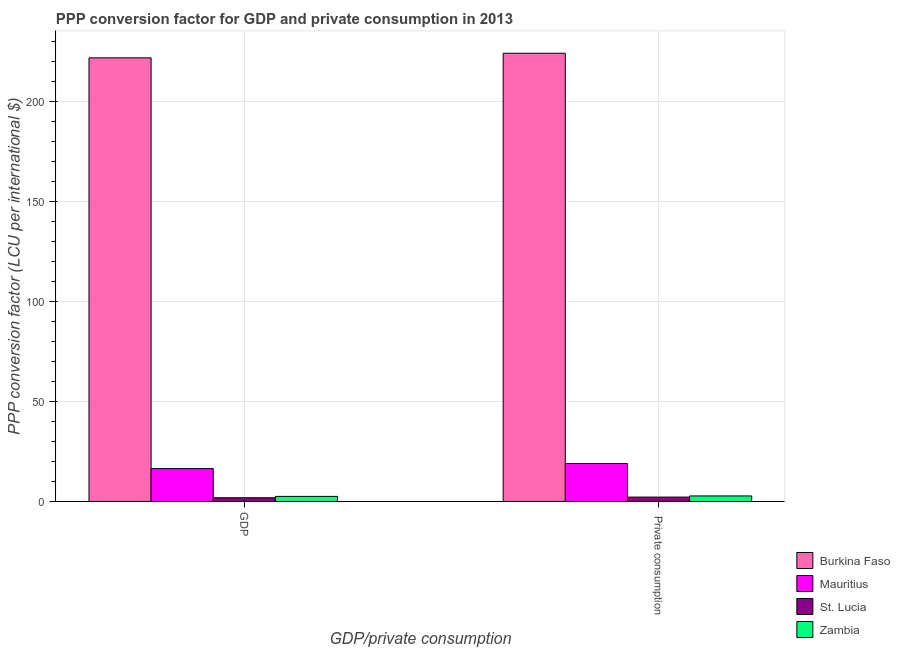How many different coloured bars are there?
Keep it short and to the point. 4. How many groups of bars are there?
Your response must be concise. 2. Are the number of bars per tick equal to the number of legend labels?
Your answer should be compact. Yes. Are the number of bars on each tick of the X-axis equal?
Your response must be concise. Yes. How many bars are there on the 1st tick from the right?
Give a very brief answer. 4. What is the label of the 2nd group of bars from the left?
Give a very brief answer.  Private consumption. What is the ppp conversion factor for private consumption in St. Lucia?
Your response must be concise. 2.18. Across all countries, what is the maximum ppp conversion factor for gdp?
Make the answer very short. 221.68. Across all countries, what is the minimum ppp conversion factor for gdp?
Offer a very short reply. 1.86. In which country was the ppp conversion factor for private consumption maximum?
Provide a short and direct response. Burkina Faso. In which country was the ppp conversion factor for gdp minimum?
Offer a very short reply. St. Lucia. What is the total ppp conversion factor for private consumption in the graph?
Offer a very short reply. 247.9. What is the difference between the ppp conversion factor for gdp in St. Lucia and that in Mauritius?
Ensure brevity in your answer.  -14.57. What is the difference between the ppp conversion factor for gdp in St. Lucia and the ppp conversion factor for private consumption in Mauritius?
Give a very brief answer. -17.12. What is the average ppp conversion factor for gdp per country?
Ensure brevity in your answer.  60.63. What is the difference between the ppp conversion factor for private consumption and ppp conversion factor for gdp in St. Lucia?
Ensure brevity in your answer.  0.32. In how many countries, is the ppp conversion factor for private consumption greater than 80 LCU?
Ensure brevity in your answer.  1. What is the ratio of the ppp conversion factor for gdp in Burkina Faso to that in Mauritius?
Your response must be concise. 13.49. What does the 3rd bar from the left in  Private consumption represents?
Give a very brief answer. St. Lucia. What does the 2nd bar from the right in GDP represents?
Make the answer very short. St. Lucia. How many countries are there in the graph?
Your response must be concise. 4. Are the values on the major ticks of Y-axis written in scientific E-notation?
Your answer should be very brief. No. What is the title of the graph?
Provide a succinct answer. PPP conversion factor for GDP and private consumption in 2013. What is the label or title of the X-axis?
Your answer should be very brief. GDP/private consumption. What is the label or title of the Y-axis?
Make the answer very short. PPP conversion factor (LCU per international $). What is the PPP conversion factor (LCU per international $) of Burkina Faso in GDP?
Give a very brief answer. 221.68. What is the PPP conversion factor (LCU per international $) of Mauritius in GDP?
Offer a very short reply. 16.43. What is the PPP conversion factor (LCU per international $) of St. Lucia in GDP?
Provide a short and direct response. 1.86. What is the PPP conversion factor (LCU per international $) in Zambia in GDP?
Provide a succinct answer. 2.54. What is the PPP conversion factor (LCU per international $) of Burkina Faso in  Private consumption?
Offer a very short reply. 223.98. What is the PPP conversion factor (LCU per international $) of Mauritius in  Private consumption?
Your answer should be compact. 18.99. What is the PPP conversion factor (LCU per international $) of St. Lucia in  Private consumption?
Keep it short and to the point. 2.18. What is the PPP conversion factor (LCU per international $) in Zambia in  Private consumption?
Make the answer very short. 2.76. Across all GDP/private consumption, what is the maximum PPP conversion factor (LCU per international $) in Burkina Faso?
Your answer should be compact. 223.98. Across all GDP/private consumption, what is the maximum PPP conversion factor (LCU per international $) in Mauritius?
Provide a succinct answer. 18.99. Across all GDP/private consumption, what is the maximum PPP conversion factor (LCU per international $) in St. Lucia?
Offer a very short reply. 2.18. Across all GDP/private consumption, what is the maximum PPP conversion factor (LCU per international $) of Zambia?
Offer a very short reply. 2.76. Across all GDP/private consumption, what is the minimum PPP conversion factor (LCU per international $) in Burkina Faso?
Provide a short and direct response. 221.68. Across all GDP/private consumption, what is the minimum PPP conversion factor (LCU per international $) of Mauritius?
Make the answer very short. 16.43. Across all GDP/private consumption, what is the minimum PPP conversion factor (LCU per international $) of St. Lucia?
Offer a terse response. 1.86. Across all GDP/private consumption, what is the minimum PPP conversion factor (LCU per international $) in Zambia?
Give a very brief answer. 2.54. What is the total PPP conversion factor (LCU per international $) in Burkina Faso in the graph?
Your answer should be very brief. 445.65. What is the total PPP conversion factor (LCU per international $) of Mauritius in the graph?
Give a very brief answer. 35.42. What is the total PPP conversion factor (LCU per international $) in St. Lucia in the graph?
Give a very brief answer. 4.05. What is the total PPP conversion factor (LCU per international $) in Zambia in the graph?
Offer a very short reply. 5.29. What is the difference between the PPP conversion factor (LCU per international $) in Burkina Faso in GDP and that in  Private consumption?
Make the answer very short. -2.3. What is the difference between the PPP conversion factor (LCU per international $) of Mauritius in GDP and that in  Private consumption?
Make the answer very short. -2.56. What is the difference between the PPP conversion factor (LCU per international $) in St. Lucia in GDP and that in  Private consumption?
Your response must be concise. -0.32. What is the difference between the PPP conversion factor (LCU per international $) in Zambia in GDP and that in  Private consumption?
Give a very brief answer. -0.22. What is the difference between the PPP conversion factor (LCU per international $) in Burkina Faso in GDP and the PPP conversion factor (LCU per international $) in Mauritius in  Private consumption?
Provide a succinct answer. 202.69. What is the difference between the PPP conversion factor (LCU per international $) in Burkina Faso in GDP and the PPP conversion factor (LCU per international $) in St. Lucia in  Private consumption?
Your answer should be very brief. 219.5. What is the difference between the PPP conversion factor (LCU per international $) of Burkina Faso in GDP and the PPP conversion factor (LCU per international $) of Zambia in  Private consumption?
Provide a succinct answer. 218.92. What is the difference between the PPP conversion factor (LCU per international $) in Mauritius in GDP and the PPP conversion factor (LCU per international $) in St. Lucia in  Private consumption?
Offer a terse response. 14.25. What is the difference between the PPP conversion factor (LCU per international $) in Mauritius in GDP and the PPP conversion factor (LCU per international $) in Zambia in  Private consumption?
Your answer should be very brief. 13.67. What is the difference between the PPP conversion factor (LCU per international $) of St. Lucia in GDP and the PPP conversion factor (LCU per international $) of Zambia in  Private consumption?
Give a very brief answer. -0.9. What is the average PPP conversion factor (LCU per international $) of Burkina Faso per GDP/private consumption?
Provide a succinct answer. 222.83. What is the average PPP conversion factor (LCU per international $) of Mauritius per GDP/private consumption?
Offer a very short reply. 17.71. What is the average PPP conversion factor (LCU per international $) in St. Lucia per GDP/private consumption?
Your answer should be very brief. 2.02. What is the average PPP conversion factor (LCU per international $) in Zambia per GDP/private consumption?
Your answer should be compact. 2.65. What is the difference between the PPP conversion factor (LCU per international $) of Burkina Faso and PPP conversion factor (LCU per international $) of Mauritius in GDP?
Your answer should be compact. 205.25. What is the difference between the PPP conversion factor (LCU per international $) in Burkina Faso and PPP conversion factor (LCU per international $) in St. Lucia in GDP?
Your answer should be very brief. 219.82. What is the difference between the PPP conversion factor (LCU per international $) in Burkina Faso and PPP conversion factor (LCU per international $) in Zambia in GDP?
Your response must be concise. 219.14. What is the difference between the PPP conversion factor (LCU per international $) of Mauritius and PPP conversion factor (LCU per international $) of St. Lucia in GDP?
Give a very brief answer. 14.57. What is the difference between the PPP conversion factor (LCU per international $) of Mauritius and PPP conversion factor (LCU per international $) of Zambia in GDP?
Ensure brevity in your answer.  13.89. What is the difference between the PPP conversion factor (LCU per international $) in St. Lucia and PPP conversion factor (LCU per international $) in Zambia in GDP?
Your answer should be very brief. -0.67. What is the difference between the PPP conversion factor (LCU per international $) in Burkina Faso and PPP conversion factor (LCU per international $) in Mauritius in  Private consumption?
Give a very brief answer. 204.99. What is the difference between the PPP conversion factor (LCU per international $) of Burkina Faso and PPP conversion factor (LCU per international $) of St. Lucia in  Private consumption?
Your response must be concise. 221.79. What is the difference between the PPP conversion factor (LCU per international $) in Burkina Faso and PPP conversion factor (LCU per international $) in Zambia in  Private consumption?
Keep it short and to the point. 221.22. What is the difference between the PPP conversion factor (LCU per international $) of Mauritius and PPP conversion factor (LCU per international $) of St. Lucia in  Private consumption?
Ensure brevity in your answer.  16.8. What is the difference between the PPP conversion factor (LCU per international $) in Mauritius and PPP conversion factor (LCU per international $) in Zambia in  Private consumption?
Your answer should be compact. 16.23. What is the difference between the PPP conversion factor (LCU per international $) in St. Lucia and PPP conversion factor (LCU per international $) in Zambia in  Private consumption?
Provide a short and direct response. -0.57. What is the ratio of the PPP conversion factor (LCU per international $) in Mauritius in GDP to that in  Private consumption?
Your answer should be very brief. 0.87. What is the ratio of the PPP conversion factor (LCU per international $) of St. Lucia in GDP to that in  Private consumption?
Offer a terse response. 0.85. What is the ratio of the PPP conversion factor (LCU per international $) of Zambia in GDP to that in  Private consumption?
Make the answer very short. 0.92. What is the difference between the highest and the second highest PPP conversion factor (LCU per international $) of Burkina Faso?
Give a very brief answer. 2.3. What is the difference between the highest and the second highest PPP conversion factor (LCU per international $) of Mauritius?
Your answer should be very brief. 2.56. What is the difference between the highest and the second highest PPP conversion factor (LCU per international $) in St. Lucia?
Give a very brief answer. 0.32. What is the difference between the highest and the second highest PPP conversion factor (LCU per international $) of Zambia?
Your answer should be very brief. 0.22. What is the difference between the highest and the lowest PPP conversion factor (LCU per international $) in Burkina Faso?
Your answer should be very brief. 2.3. What is the difference between the highest and the lowest PPP conversion factor (LCU per international $) in Mauritius?
Provide a short and direct response. 2.56. What is the difference between the highest and the lowest PPP conversion factor (LCU per international $) of St. Lucia?
Your answer should be very brief. 0.32. What is the difference between the highest and the lowest PPP conversion factor (LCU per international $) of Zambia?
Offer a very short reply. 0.22. 